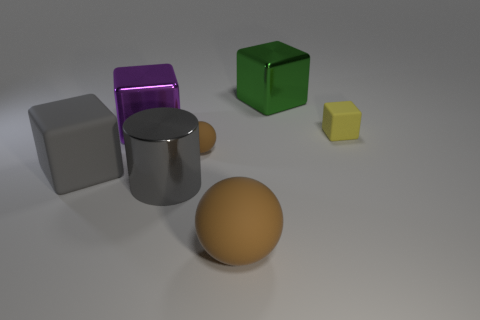Can you describe the sizes and colors of the objects presented in this image? Certainly! The image showcases a variety of objects with different sizes and colors. There's a large purple cube, a big metal cube that seems to have a matte finish, and a large green cube with a reflective surface. Additionally, there's a small yellow cube and a mid-sized orange-brown sphere on display. The objects are placed against a neutral background that enhances their visibility. 